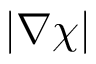Convert formula to latex. <formula><loc_0><loc_0><loc_500><loc_500>| \nabla \chi |</formula> 